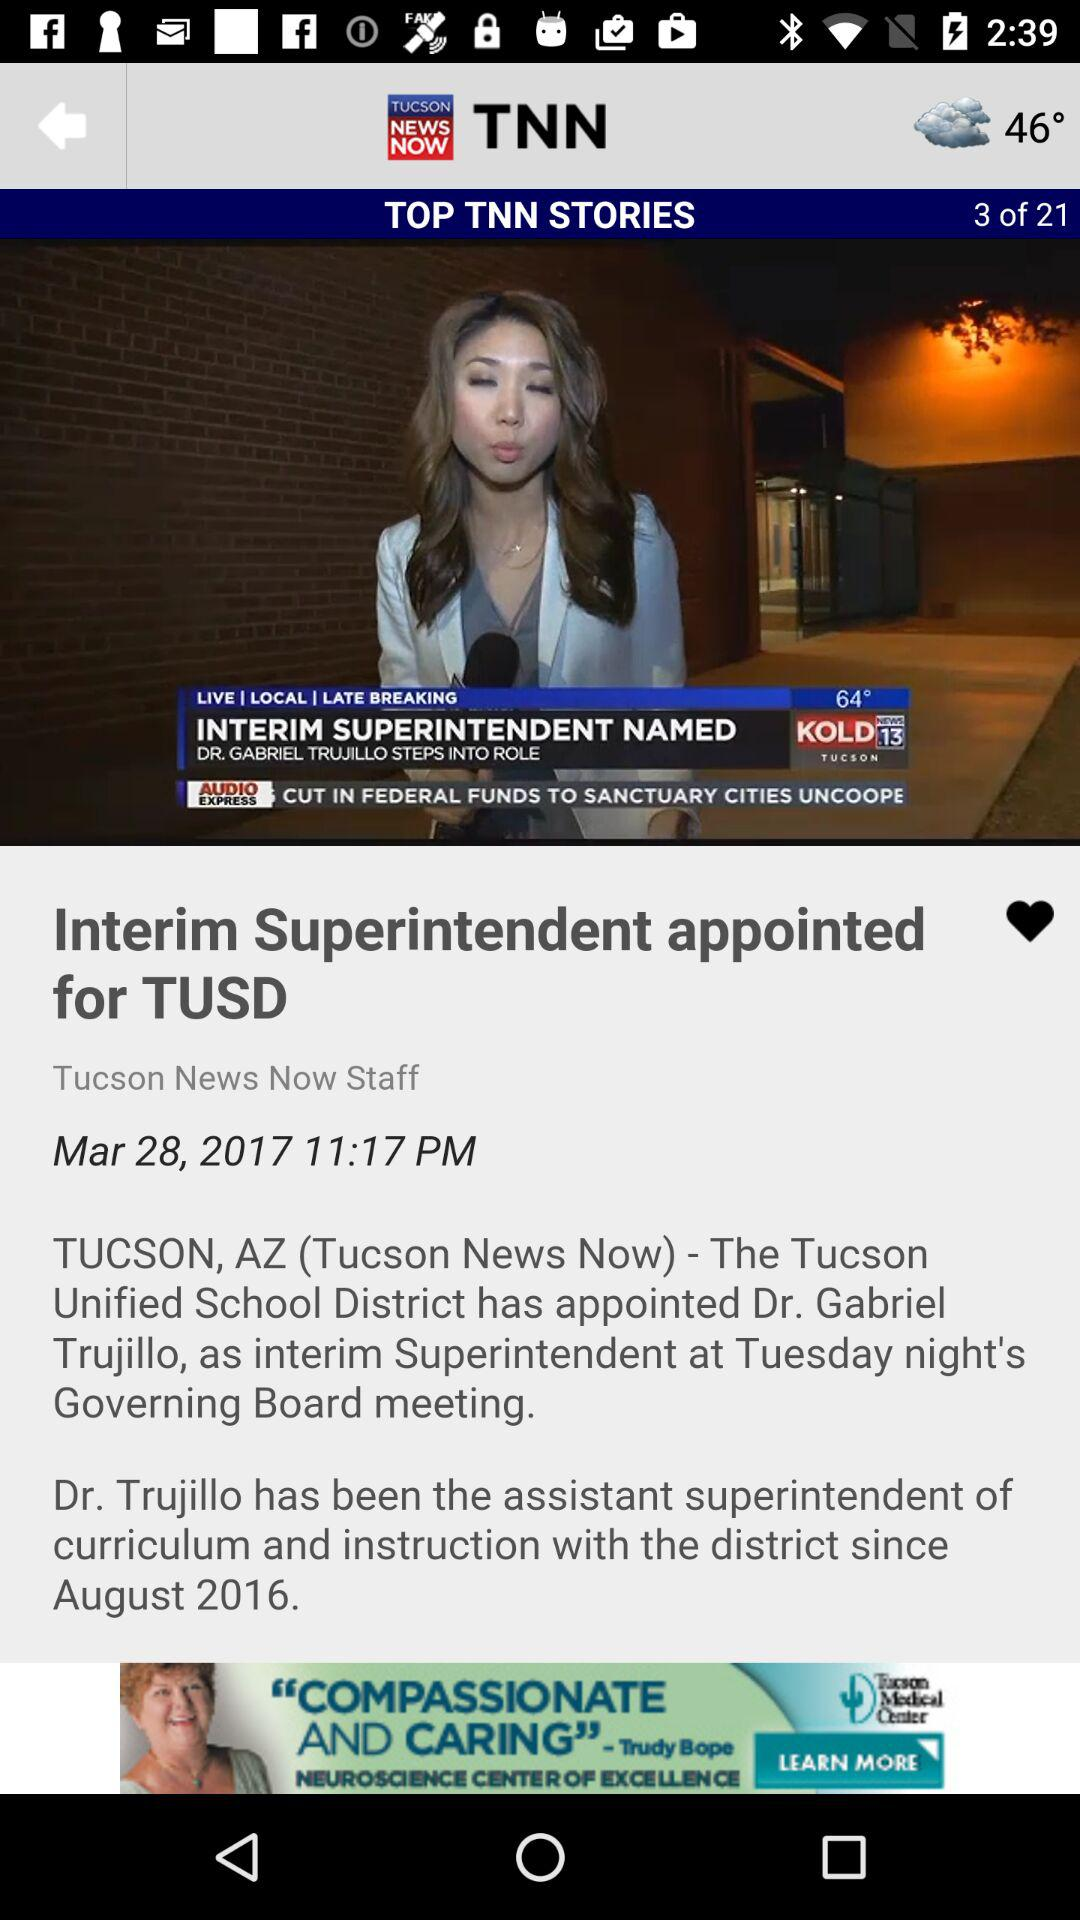At which story number is the user currently? The user is currently at story number 3. 